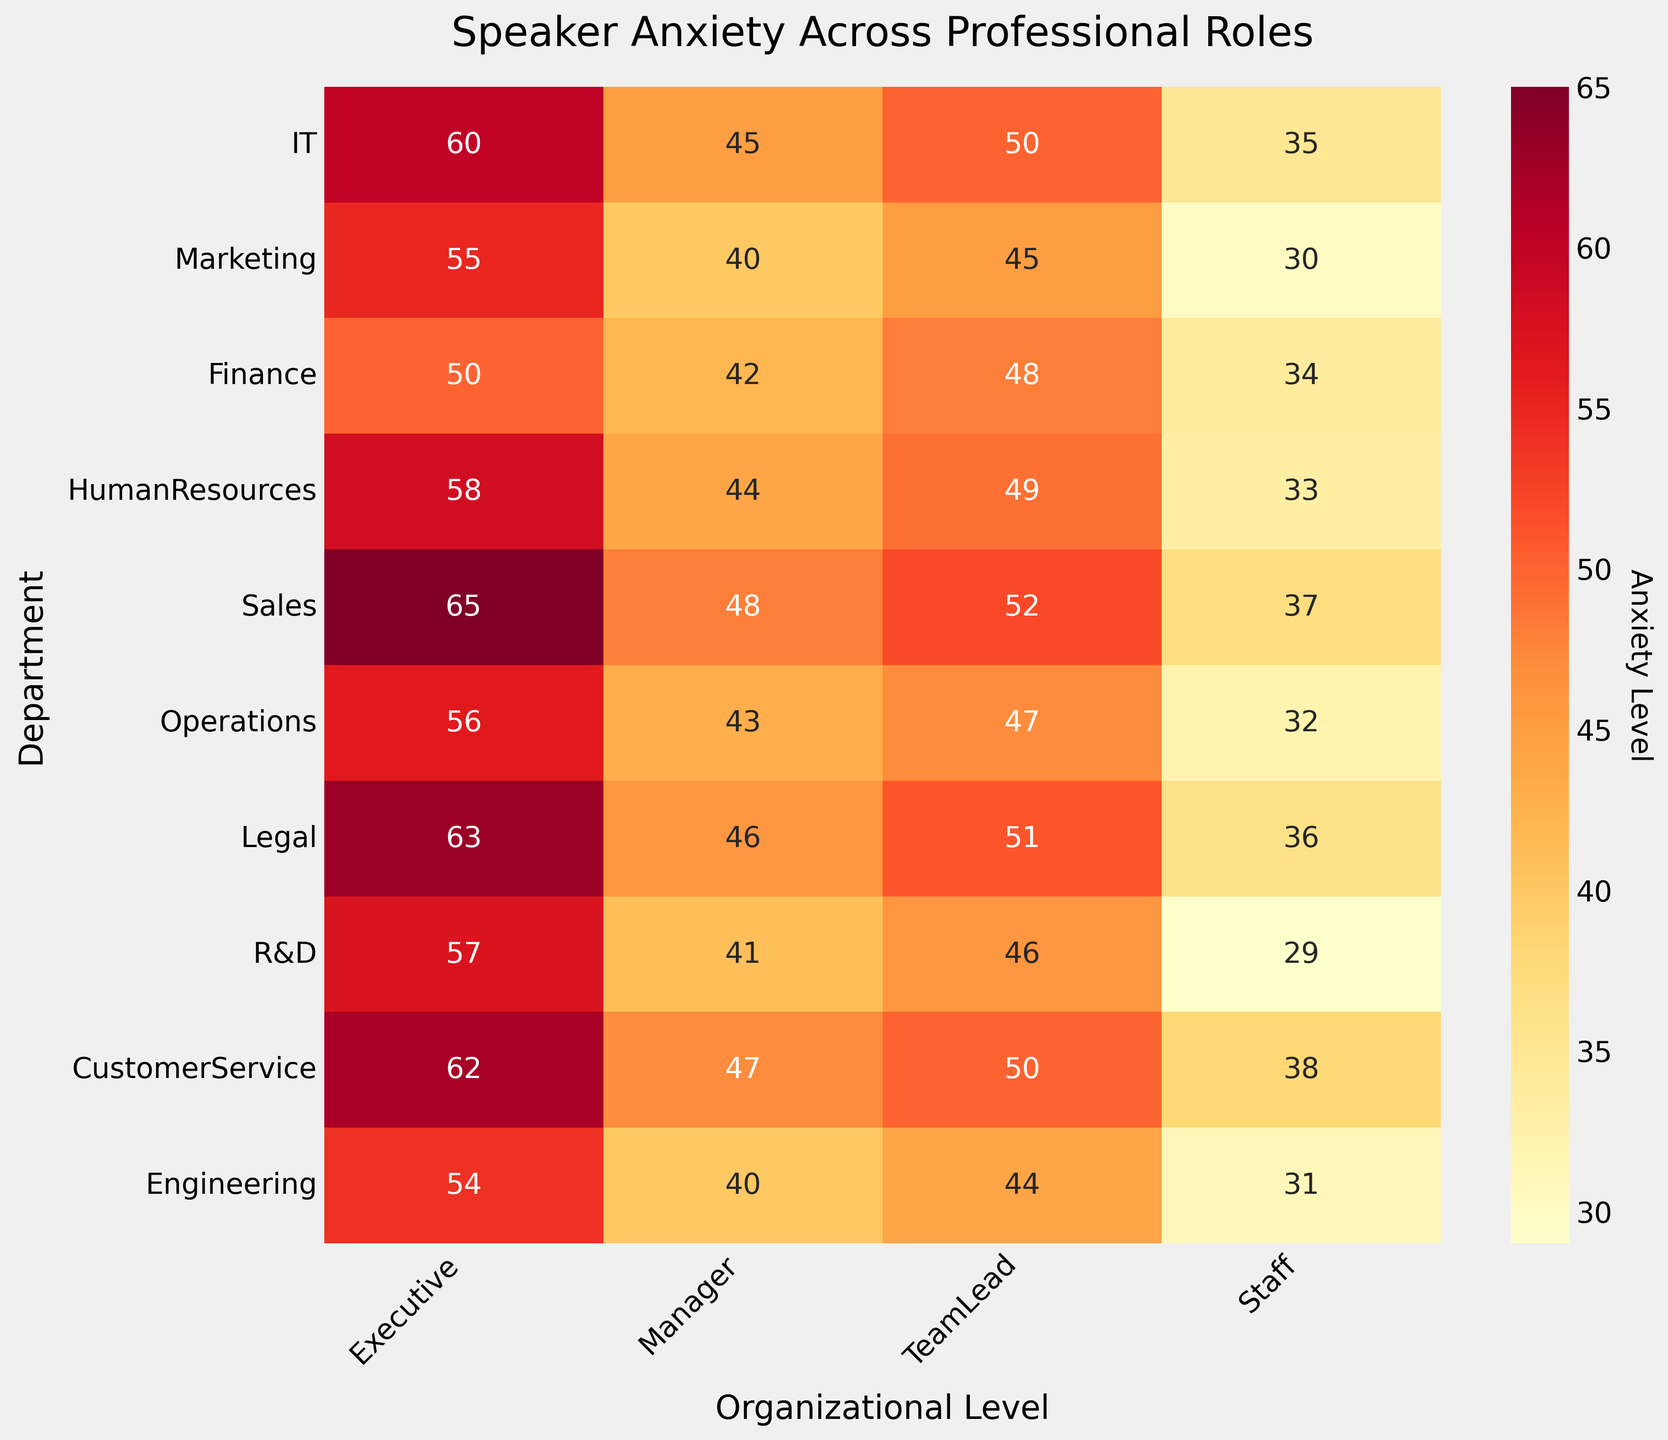What's the title of the heatmap? The title of the heatmap is prominently displayed at the top of the figure.
Answer: Speaker Anxiety Across Professional Roles What do the colors on the heatmap represent? The colors on the heatmap represent the levels of speaker anxiety, with a color scale that varies from yellow (lower anxiety) to red (higher anxiety).
Answer: Anxiety levels Which professional role in the Sales department experiences the highest speaker anxiety? Locate the "Sales" row on the y-axis and identify the highest value in that row, which corresponds to the executive level.
Answer: Executive How does the anxiety level of Marketing Managers compare to Marketing Executives? Find the anxiety levels in the Marketing row for both the Manager and Executive columns: 40 for Managers and 55 for Executives. Executives exhibit higher anxiety.
Answer: Executives have higher anxiety What is the average anxiety level for IT department across all professional roles? Sum the anxiety values for the IT department (60, 45, 50, 35) and divide by the number of roles (4). The calculation is (60 + 45 + 50 + 35) / 4 = 47.5.
Answer: 47.5 Which department shows the highest anxiety level for Team Leads? Compare the anxiety levels of all departments specifically for the Team Lead column. The highest value in the Team Lead column is 52, found in the Sales department.
Answer: Sales Are there any departments where the staff level has higher anxiety than the Manager level? Compare the values for Staff and Manager levels across all departments. No such scenario exists as Manager values are consistently higher than Staff values in each department.
Answer: No What is the range of anxiety levels in the Legal department? Identify the minimum and maximum values in the Legal row: 36 (Staff) and 63 (Executive). The range is the difference, 63 - 36 = 27.
Answer: 27 Which role in Engineering experiences the least anxiety? In the Engineering row, identify the smallest value which is for the Staff level with an anxiety level of 31.
Answer: Staff What is the difference in anxiety levels between the Executives in Customer Service and Human Resources departments? Compare anxiety values for Executives in Customer Service (62) and Human Resources (58). The difference is 62 - 58 = 4.
Answer: 4 